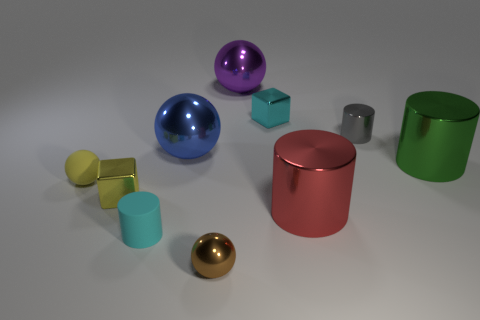Can you describe the lighting setup that might have been used to create the reflections on the objects? The reflections on the objects suggest a diffused lighting setup, likely featuring multiple light sources above and around the scene to create soft shadows and the varied highlights on the metallic surfaces. 